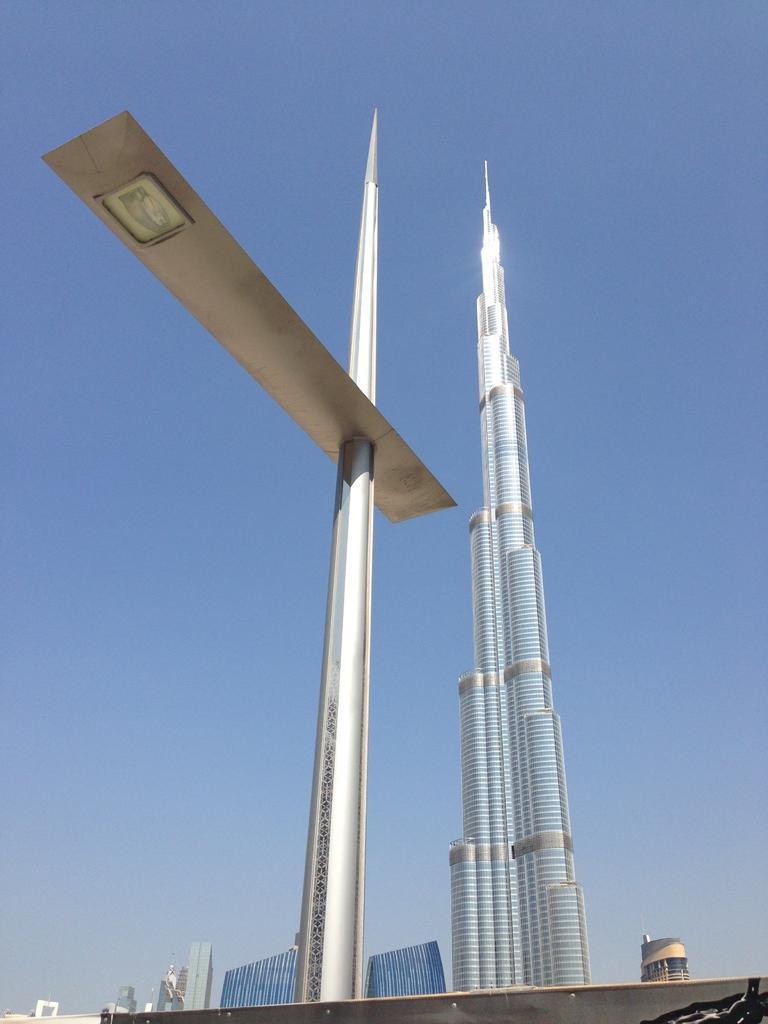In one or two sentences, can you explain what this image depicts? In this picture we can see a pole with an object. Behind the pole, there is a skyscraper, buildings and the sky. 